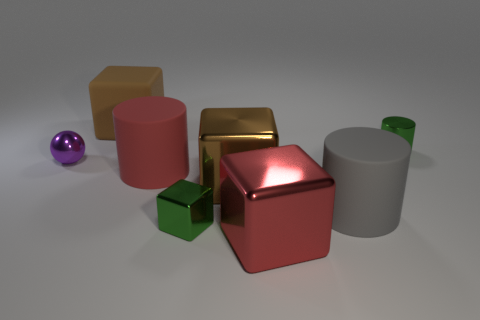The other brown thing that is the same shape as the brown metallic object is what size?
Provide a short and direct response. Large. The big gray rubber thing is what shape?
Provide a succinct answer. Cylinder. Is the red cylinder made of the same material as the brown thing behind the metallic cylinder?
Make the answer very short. Yes. How many matte things are either yellow balls or big red things?
Keep it short and to the point. 1. What size is the gray rubber cylinder that is in front of the small shiny cylinder?
Make the answer very short. Large. What is the size of the brown block that is made of the same material as the purple sphere?
Give a very brief answer. Large. What number of metallic blocks have the same color as the metallic cylinder?
Offer a terse response. 1. Are there any purple metal balls?
Give a very brief answer. Yes. There is a small purple thing; does it have the same shape as the green thing that is in front of the small metallic cylinder?
Your answer should be very brief. No. There is a large metallic object behind the large shiny block that is on the right side of the large brown block that is on the right side of the brown matte block; what is its color?
Offer a very short reply. Brown. 